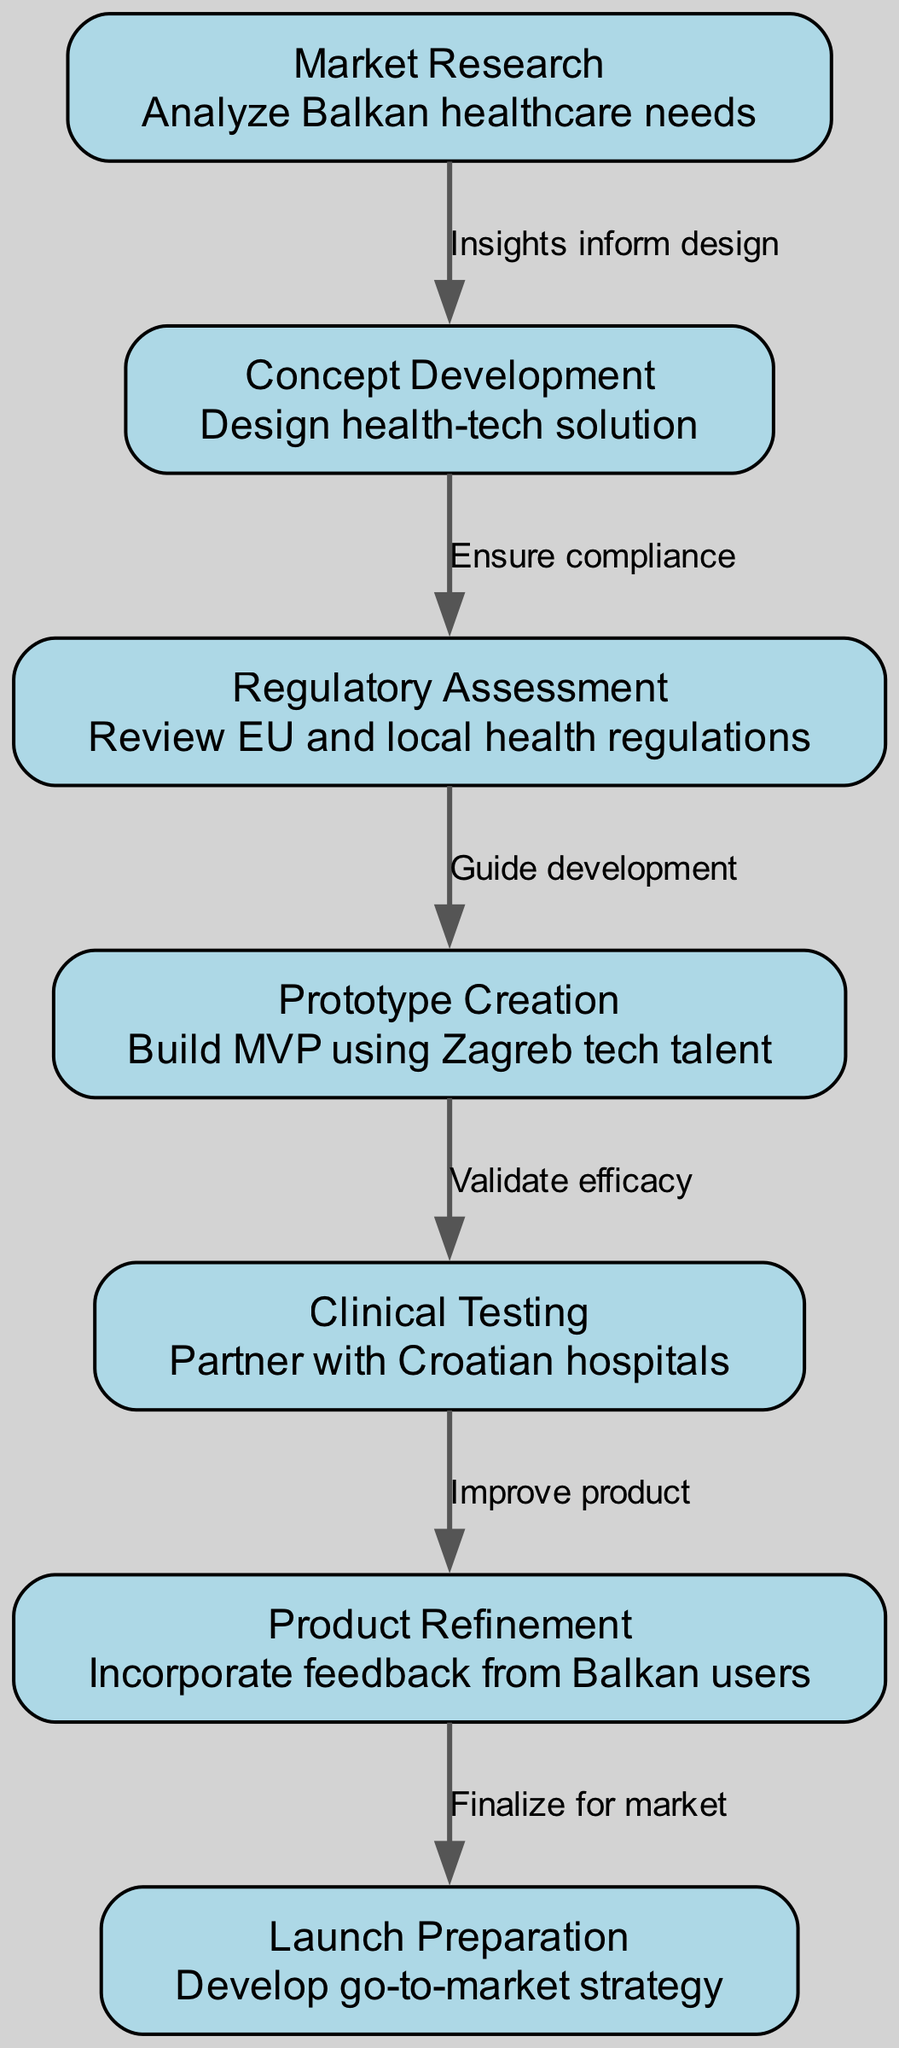What is the first step in the product development lifecycle? The diagram indicates that the first step is "Market Research," which focuses on analyzing Balkan healthcare needs.
Answer: Market Research How many nodes are in the diagram? Counting the nodes listed in the diagram shows there are seven distinct steps in the product development lifecycle.
Answer: 7 What steps directly follow "Prototype Creation"? According to the diagram, "Clinical Testing" directly follows "Prototype Creation" as indicated by the directed edge connecting these two nodes.
Answer: Clinical Testing What is the purpose of "Regulatory Assessment"? The diagram describes "Regulatory Assessment" as reviewing EU and local health regulations, which ensures that the product complies with necessary standards.
Answer: Review EU and local health regulations What is the final step before launching the product? The final step before preparing for the market launch is "Product Refinement," where feedback from users is incorporated into the health-tech solution.
Answer: Product Refinement Which step involves building the MVP? The diagram states that "Prototype Creation" is the step where the minimum viable product (MVP) is built, utilizing tech talent from Zagreb.
Answer: Prototype Creation What do the insights from "Market Research" inform? The insights gathered from "Market Research" inform the design of the health-tech solution during the "Concept Development" phase.
Answer: Design health-tech solution What is the relationship between "Clinical Testing" and "Product Refinement"? The diagram indicates that "Clinical Testing" precedes "Product Refinement," and the edge between them suggests that results from testing improve the product.
Answer: Improve product 